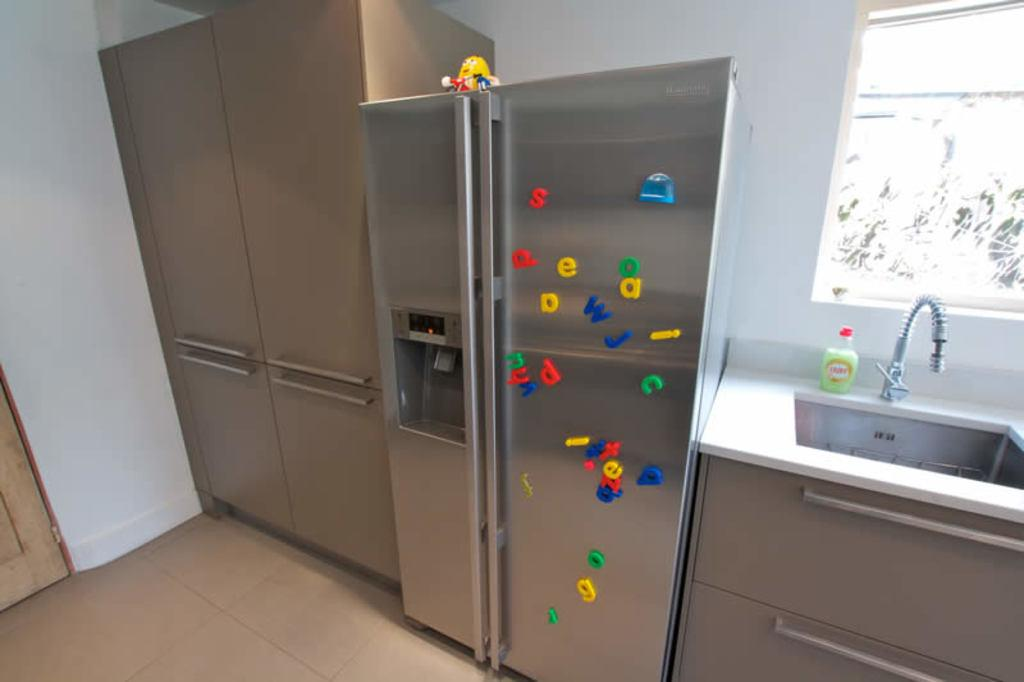<image>
Relay a brief, clear account of the picture shown. a stainless steel fridge with magnetic letters of s, d, e, and a on it. 